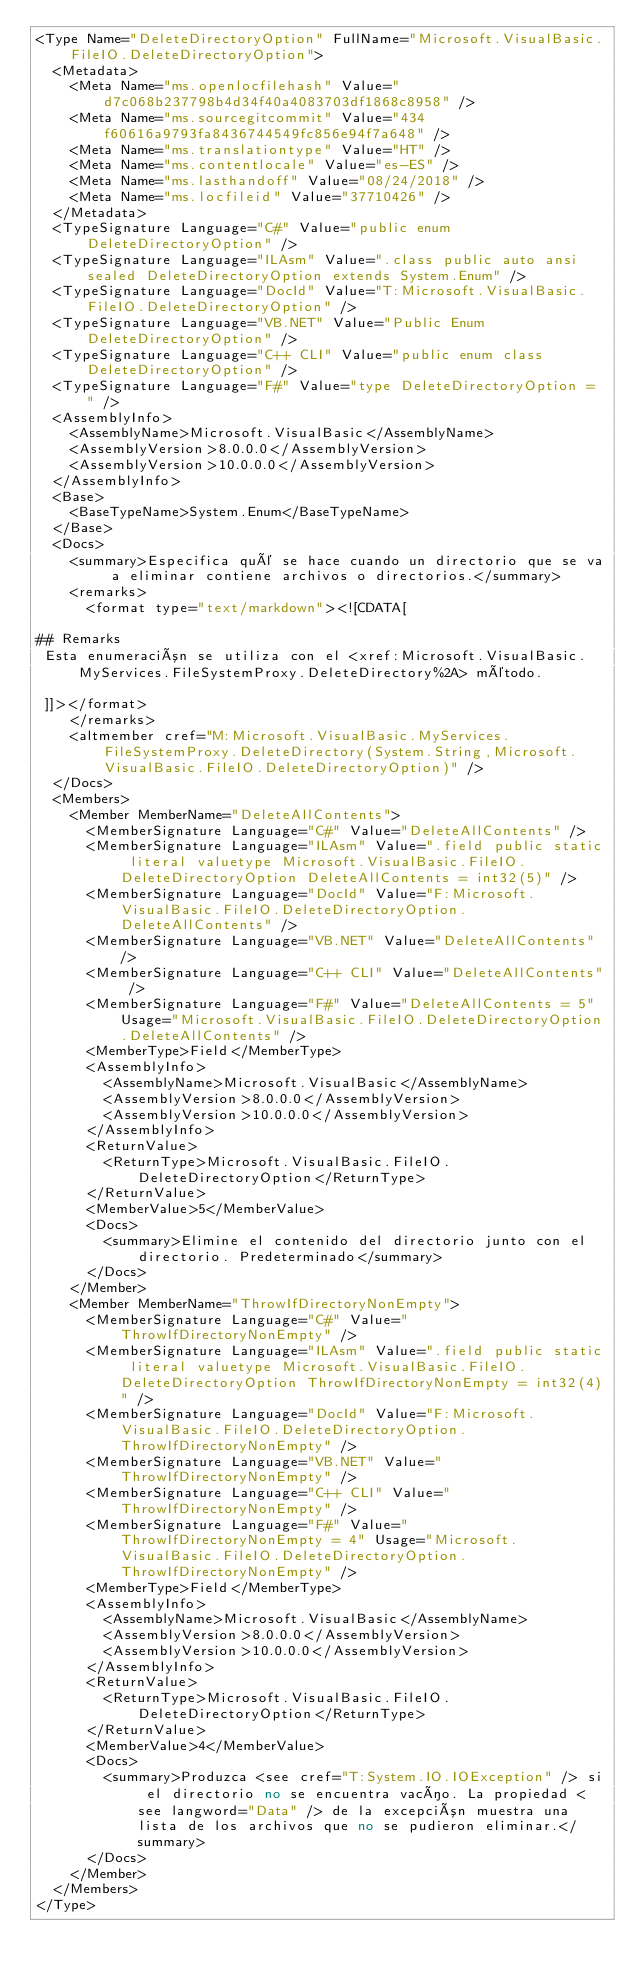Convert code to text. <code><loc_0><loc_0><loc_500><loc_500><_XML_><Type Name="DeleteDirectoryOption" FullName="Microsoft.VisualBasic.FileIO.DeleteDirectoryOption">
  <Metadata>
    <Meta Name="ms.openlocfilehash" Value="d7c068b237798b4d34f40a4083703df1868c8958" />
    <Meta Name="ms.sourcegitcommit" Value="434f60616a9793fa8436744549fc856e94f7a648" />
    <Meta Name="ms.translationtype" Value="HT" />
    <Meta Name="ms.contentlocale" Value="es-ES" />
    <Meta Name="ms.lasthandoff" Value="08/24/2018" />
    <Meta Name="ms.locfileid" Value="37710426" />
  </Metadata>
  <TypeSignature Language="C#" Value="public enum DeleteDirectoryOption" />
  <TypeSignature Language="ILAsm" Value=".class public auto ansi sealed DeleteDirectoryOption extends System.Enum" />
  <TypeSignature Language="DocId" Value="T:Microsoft.VisualBasic.FileIO.DeleteDirectoryOption" />
  <TypeSignature Language="VB.NET" Value="Public Enum DeleteDirectoryOption" />
  <TypeSignature Language="C++ CLI" Value="public enum class DeleteDirectoryOption" />
  <TypeSignature Language="F#" Value="type DeleteDirectoryOption = " />
  <AssemblyInfo>
    <AssemblyName>Microsoft.VisualBasic</AssemblyName>
    <AssemblyVersion>8.0.0.0</AssemblyVersion>
    <AssemblyVersion>10.0.0.0</AssemblyVersion>
  </AssemblyInfo>
  <Base>
    <BaseTypeName>System.Enum</BaseTypeName>
  </Base>
  <Docs>
    <summary>Especifica qué se hace cuando un directorio que se va a eliminar contiene archivos o directorios.</summary>
    <remarks>
      <format type="text/markdown"><![CDATA[  
  
## Remarks  
 Esta enumeración se utiliza con el <xref:Microsoft.VisualBasic.MyServices.FileSystemProxy.DeleteDirectory%2A> método.  
  
 ]]></format>
    </remarks>
    <altmember cref="M:Microsoft.VisualBasic.MyServices.FileSystemProxy.DeleteDirectory(System.String,Microsoft.VisualBasic.FileIO.DeleteDirectoryOption)" />
  </Docs>
  <Members>
    <Member MemberName="DeleteAllContents">
      <MemberSignature Language="C#" Value="DeleteAllContents" />
      <MemberSignature Language="ILAsm" Value=".field public static literal valuetype Microsoft.VisualBasic.FileIO.DeleteDirectoryOption DeleteAllContents = int32(5)" />
      <MemberSignature Language="DocId" Value="F:Microsoft.VisualBasic.FileIO.DeleteDirectoryOption.DeleteAllContents" />
      <MemberSignature Language="VB.NET" Value="DeleteAllContents" />
      <MemberSignature Language="C++ CLI" Value="DeleteAllContents" />
      <MemberSignature Language="F#" Value="DeleteAllContents = 5" Usage="Microsoft.VisualBasic.FileIO.DeleteDirectoryOption.DeleteAllContents" />
      <MemberType>Field</MemberType>
      <AssemblyInfo>
        <AssemblyName>Microsoft.VisualBasic</AssemblyName>
        <AssemblyVersion>8.0.0.0</AssemblyVersion>
        <AssemblyVersion>10.0.0.0</AssemblyVersion>
      </AssemblyInfo>
      <ReturnValue>
        <ReturnType>Microsoft.VisualBasic.FileIO.DeleteDirectoryOption</ReturnType>
      </ReturnValue>
      <MemberValue>5</MemberValue>
      <Docs>
        <summary>Elimine el contenido del directorio junto con el directorio. Predeterminado</summary>
      </Docs>
    </Member>
    <Member MemberName="ThrowIfDirectoryNonEmpty">
      <MemberSignature Language="C#" Value="ThrowIfDirectoryNonEmpty" />
      <MemberSignature Language="ILAsm" Value=".field public static literal valuetype Microsoft.VisualBasic.FileIO.DeleteDirectoryOption ThrowIfDirectoryNonEmpty = int32(4)" />
      <MemberSignature Language="DocId" Value="F:Microsoft.VisualBasic.FileIO.DeleteDirectoryOption.ThrowIfDirectoryNonEmpty" />
      <MemberSignature Language="VB.NET" Value="ThrowIfDirectoryNonEmpty" />
      <MemberSignature Language="C++ CLI" Value="ThrowIfDirectoryNonEmpty" />
      <MemberSignature Language="F#" Value="ThrowIfDirectoryNonEmpty = 4" Usage="Microsoft.VisualBasic.FileIO.DeleteDirectoryOption.ThrowIfDirectoryNonEmpty" />
      <MemberType>Field</MemberType>
      <AssemblyInfo>
        <AssemblyName>Microsoft.VisualBasic</AssemblyName>
        <AssemblyVersion>8.0.0.0</AssemblyVersion>
        <AssemblyVersion>10.0.0.0</AssemblyVersion>
      </AssemblyInfo>
      <ReturnValue>
        <ReturnType>Microsoft.VisualBasic.FileIO.DeleteDirectoryOption</ReturnType>
      </ReturnValue>
      <MemberValue>4</MemberValue>
      <Docs>
        <summary>Produzca <see cref="T:System.IO.IOException" /> si el directorio no se encuentra vacío. La propiedad <see langword="Data" /> de la excepción muestra una lista de los archivos que no se pudieron eliminar.</summary>
      </Docs>
    </Member>
  </Members>
</Type></code> 